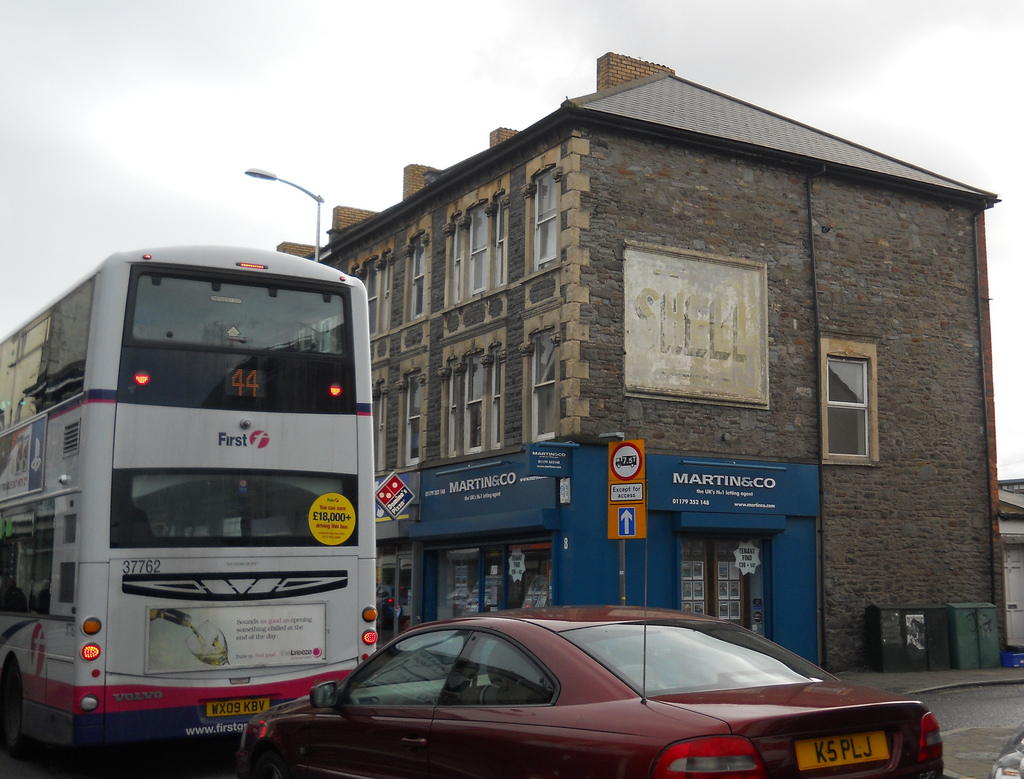Please provide the bounding box coordinate of the region this sentence describes: a narrow window in a brick building. The bounding box coordinate for the narrow window in the brick building is approximately [0.8, 0.44, 0.87, 0.59]. This marks the specific area where the narrow window is located, offering a clear and precise reference point. 